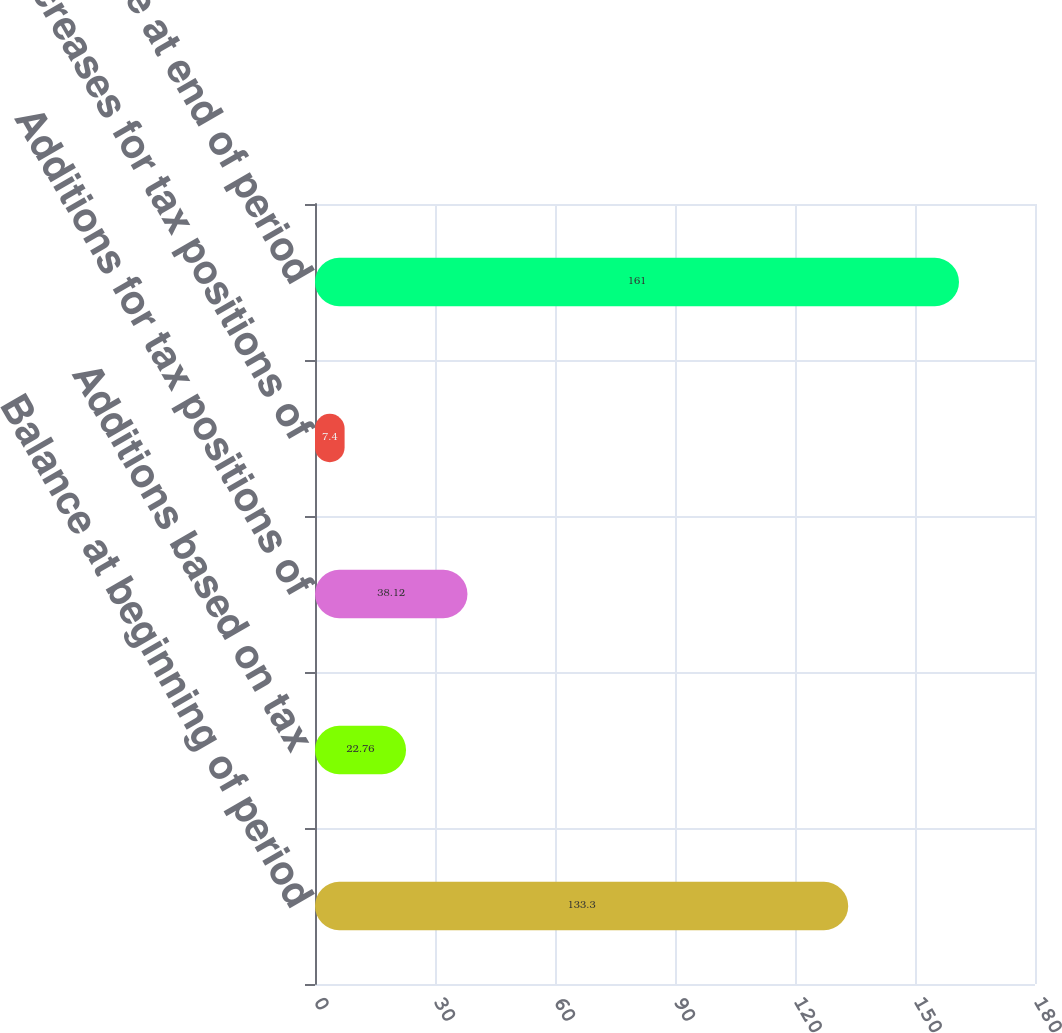Convert chart. <chart><loc_0><loc_0><loc_500><loc_500><bar_chart><fcel>Balance at beginning of period<fcel>Additions based on tax<fcel>Additions for tax positions of<fcel>Decreases for tax positions of<fcel>Balance at end of period<nl><fcel>133.3<fcel>22.76<fcel>38.12<fcel>7.4<fcel>161<nl></chart> 